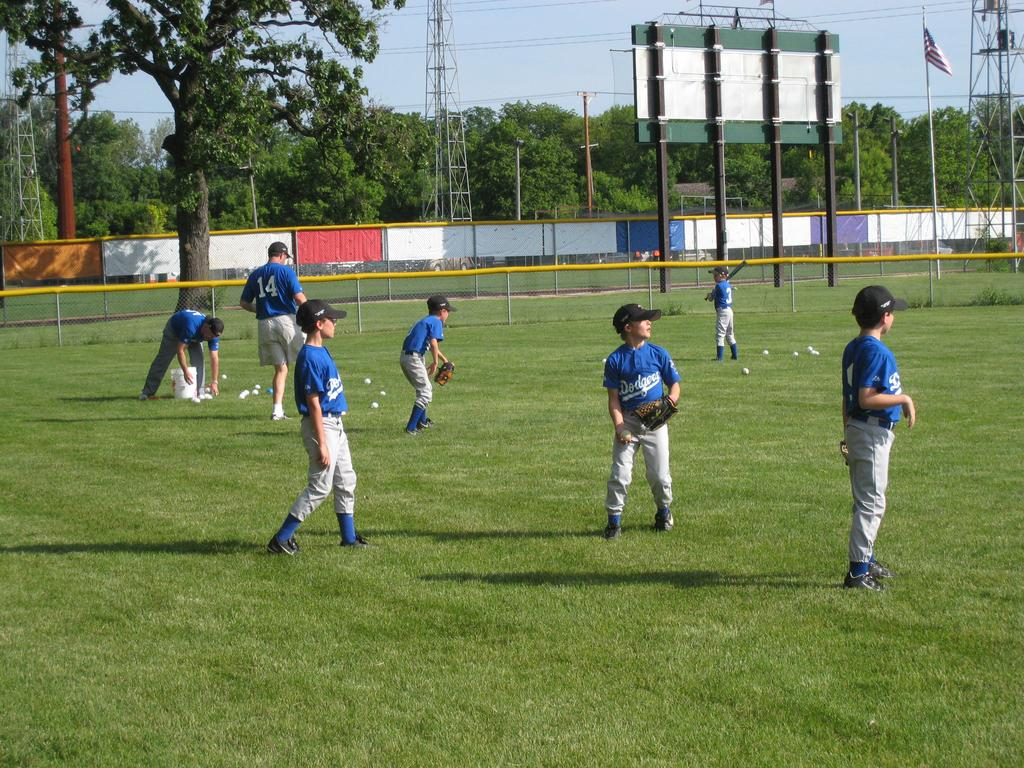<image>
Write a terse but informative summary of the picture. Baseball players waering jerseys that say  Dodgers on it. 